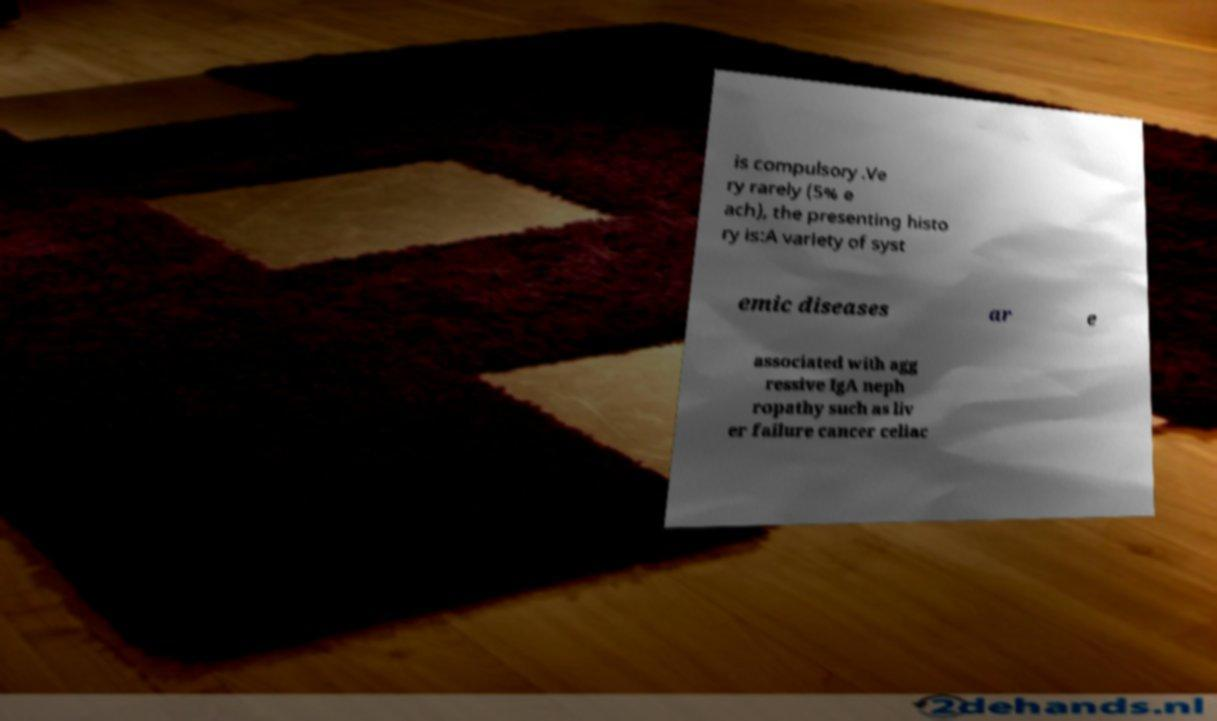What messages or text are displayed in this image? I need them in a readable, typed format. is compulsory .Ve ry rarely (5% e ach), the presenting histo ry is:A variety of syst emic diseases ar e associated with agg ressive IgA neph ropathy such as liv er failure cancer celiac 